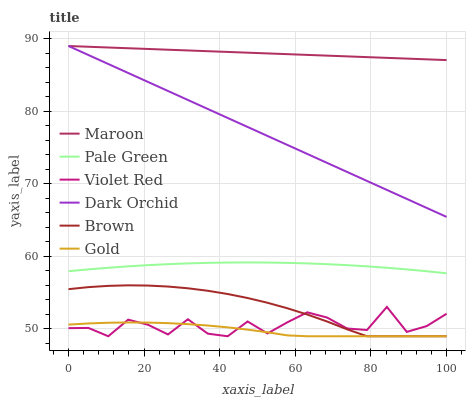Does Gold have the minimum area under the curve?
Answer yes or no. Yes. Does Maroon have the maximum area under the curve?
Answer yes or no. Yes. Does Violet Red have the minimum area under the curve?
Answer yes or no. No. Does Violet Red have the maximum area under the curve?
Answer yes or no. No. Is Maroon the smoothest?
Answer yes or no. Yes. Is Violet Red the roughest?
Answer yes or no. Yes. Is Gold the smoothest?
Answer yes or no. No. Is Gold the roughest?
Answer yes or no. No. Does Brown have the lowest value?
Answer yes or no. Yes. Does Dark Orchid have the lowest value?
Answer yes or no. No. Does Maroon have the highest value?
Answer yes or no. Yes. Does Violet Red have the highest value?
Answer yes or no. No. Is Violet Red less than Pale Green?
Answer yes or no. Yes. Is Dark Orchid greater than Violet Red?
Answer yes or no. Yes. Does Violet Red intersect Brown?
Answer yes or no. Yes. Is Violet Red less than Brown?
Answer yes or no. No. Is Violet Red greater than Brown?
Answer yes or no. No. Does Violet Red intersect Pale Green?
Answer yes or no. No. 